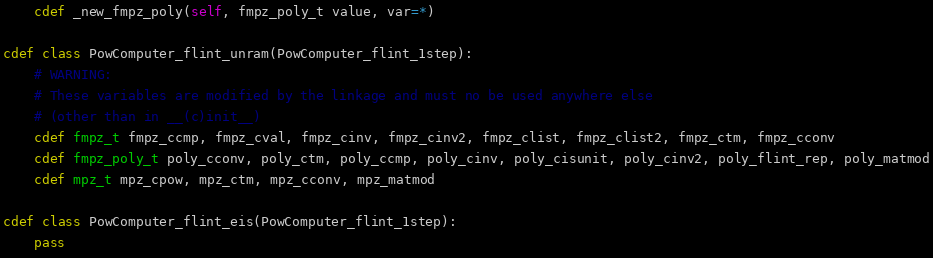<code> <loc_0><loc_0><loc_500><loc_500><_Cython_>    cdef _new_fmpz_poly(self, fmpz_poly_t value, var=*)

cdef class PowComputer_flint_unram(PowComputer_flint_1step):
    # WARNING:
    # These variables are modified by the linkage and must no be used anywhere else
    # (other than in __(c)init__)
    cdef fmpz_t fmpz_ccmp, fmpz_cval, fmpz_cinv, fmpz_cinv2, fmpz_clist, fmpz_clist2, fmpz_ctm, fmpz_cconv
    cdef fmpz_poly_t poly_cconv, poly_ctm, poly_ccmp, poly_cinv, poly_cisunit, poly_cinv2, poly_flint_rep, poly_matmod
    cdef mpz_t mpz_cpow, mpz_ctm, mpz_cconv, mpz_matmod

cdef class PowComputer_flint_eis(PowComputer_flint_1step):
    pass
</code> 